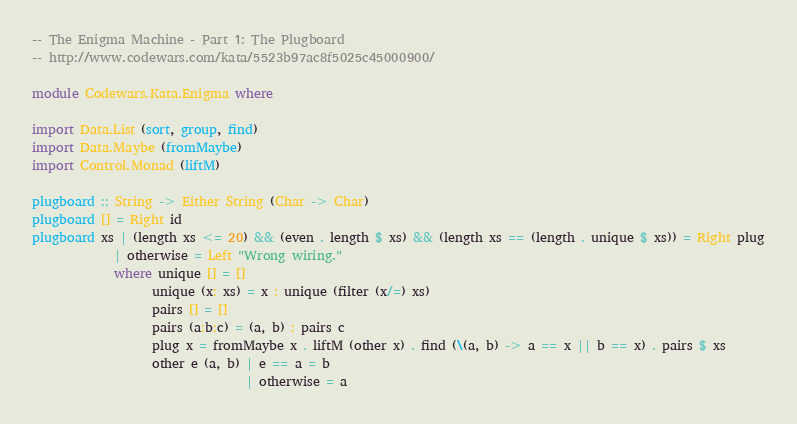Convert code to text. <code><loc_0><loc_0><loc_500><loc_500><_Haskell_>-- The Enigma Machine - Part 1: The Plugboard
-- http://www.codewars.com/kata/5523b97ac8f5025c45000900/

module Codewars.Kata.Enigma where

import Data.List (sort, group, find)
import Data.Maybe (fromMaybe)
import Control.Monad (liftM)

plugboard :: String -> Either String (Char -> Char)
plugboard [] = Right id
plugboard xs | (length xs <= 20) && (even . length $ xs) && (length xs == (length . unique $ xs)) = Right plug
             | otherwise = Left "Wrong wiring."
             where unique [] = []
                   unique (x: xs) = x : unique (filter (x/=) xs)
                   pairs [] = []
                   pairs (a:b:c) = (a, b) : pairs c
                   plug x = fromMaybe x . liftM (other x) . find (\(a, b) -> a == x || b == x) . pairs $ xs
                   other e (a, b) | e == a = b
                                  | otherwise = a
</code> 